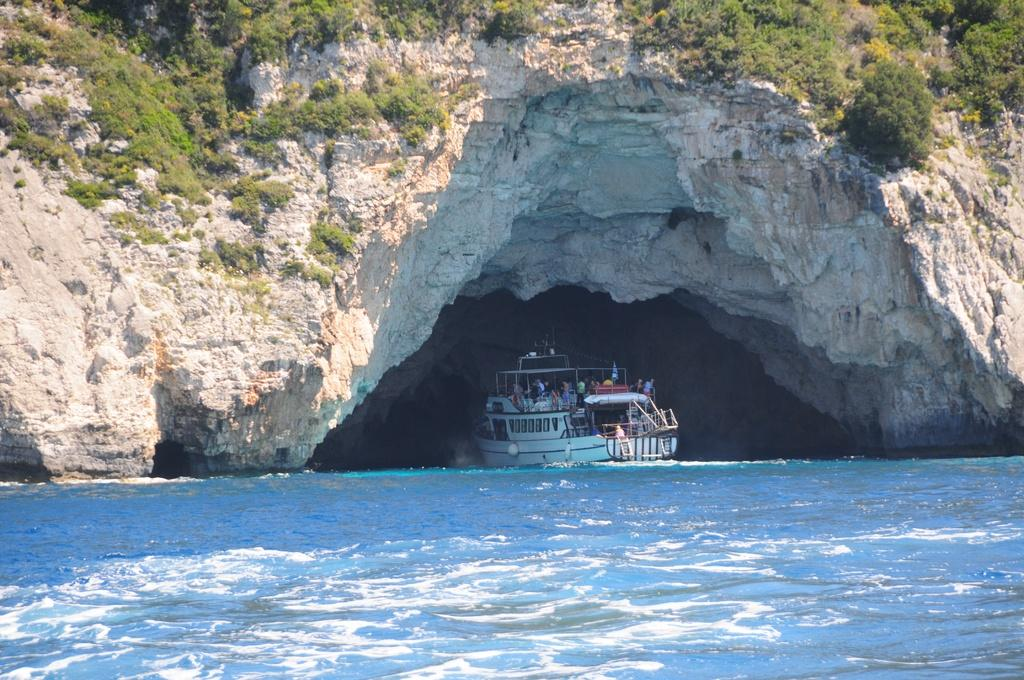What is at the bottom of the image? There is water at the bottom of the image. What can be seen floating on the water? There is a boat in the image. What type of vegetation is visible in the image? There are plants visible in the image. How many yams are being held by the manager in the image? There is no manager or yams present in the image. What type of shoes are the feet wearing in the image? There are no feet or shoes visible in the image. 